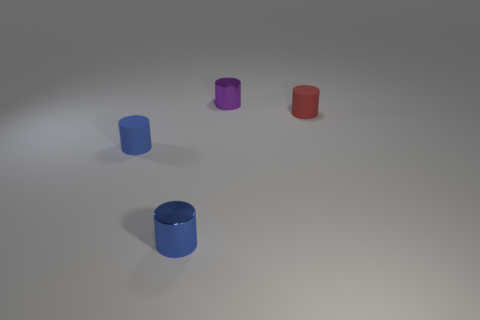Subtract 1 cylinders. How many cylinders are left? 3 Add 1 tiny blue metal cylinders. How many objects exist? 5 Subtract all tiny purple shiny objects. Subtract all tiny matte cylinders. How many objects are left? 1 Add 1 matte objects. How many matte objects are left? 3 Add 2 tiny blue matte objects. How many tiny blue matte objects exist? 3 Subtract 0 yellow cylinders. How many objects are left? 4 